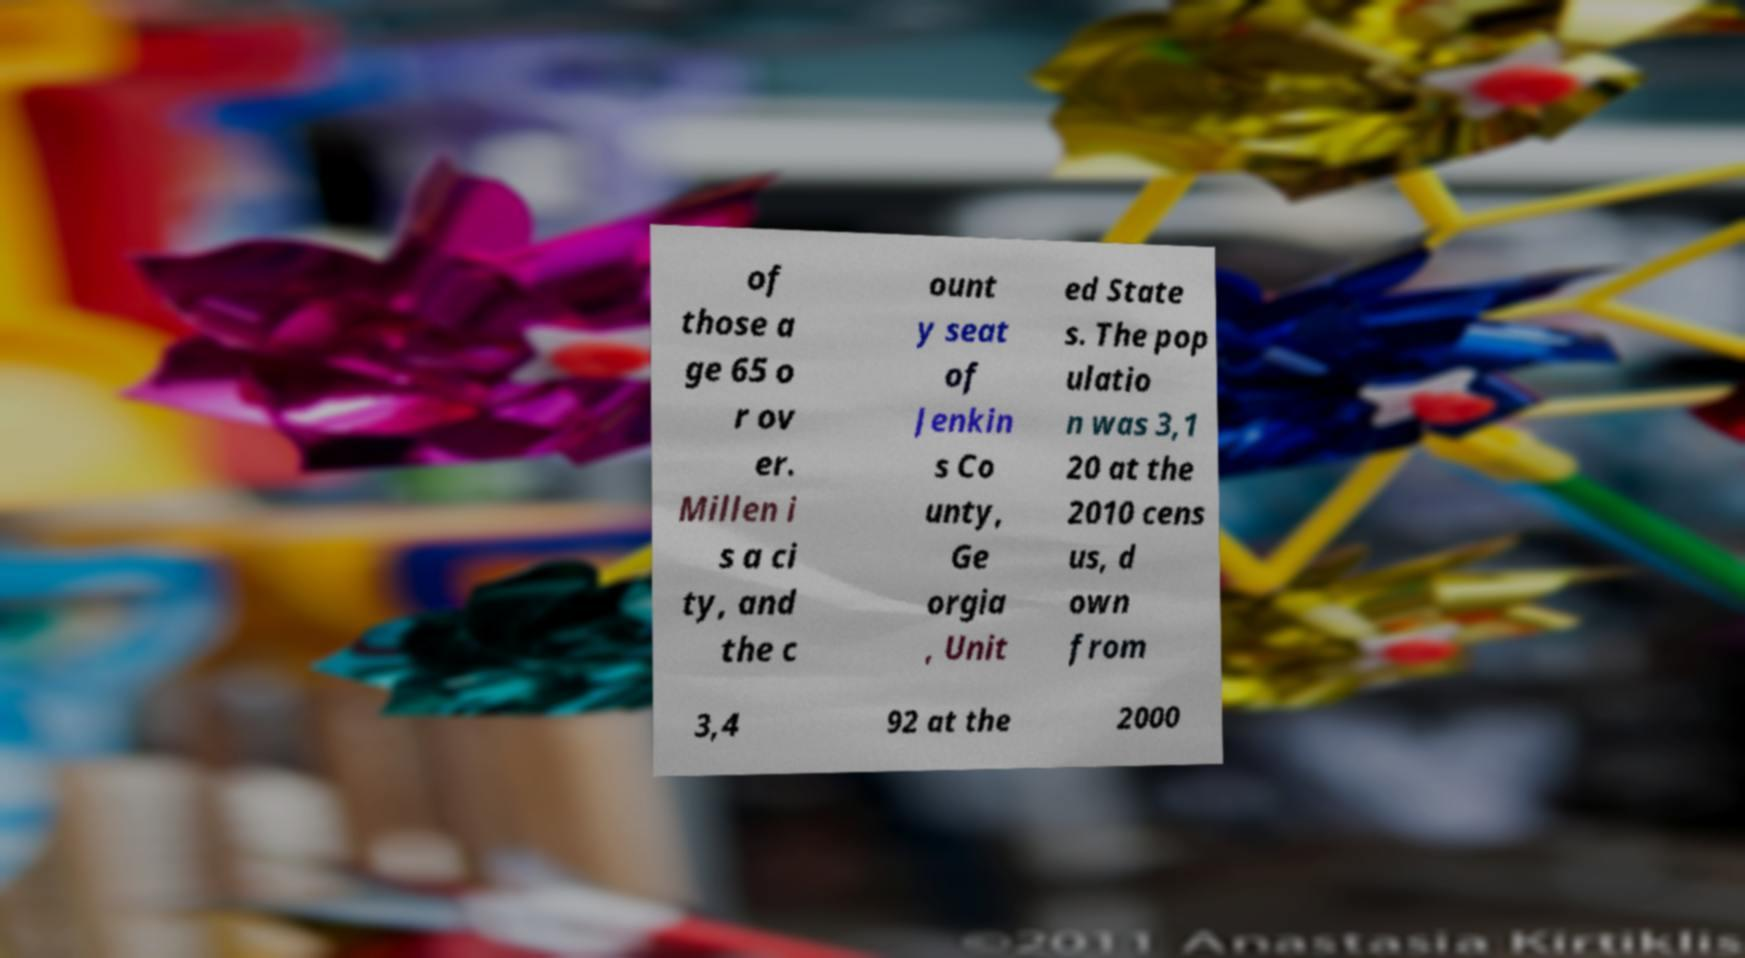For documentation purposes, I need the text within this image transcribed. Could you provide that? of those a ge 65 o r ov er. Millen i s a ci ty, and the c ount y seat of Jenkin s Co unty, Ge orgia , Unit ed State s. The pop ulatio n was 3,1 20 at the 2010 cens us, d own from 3,4 92 at the 2000 